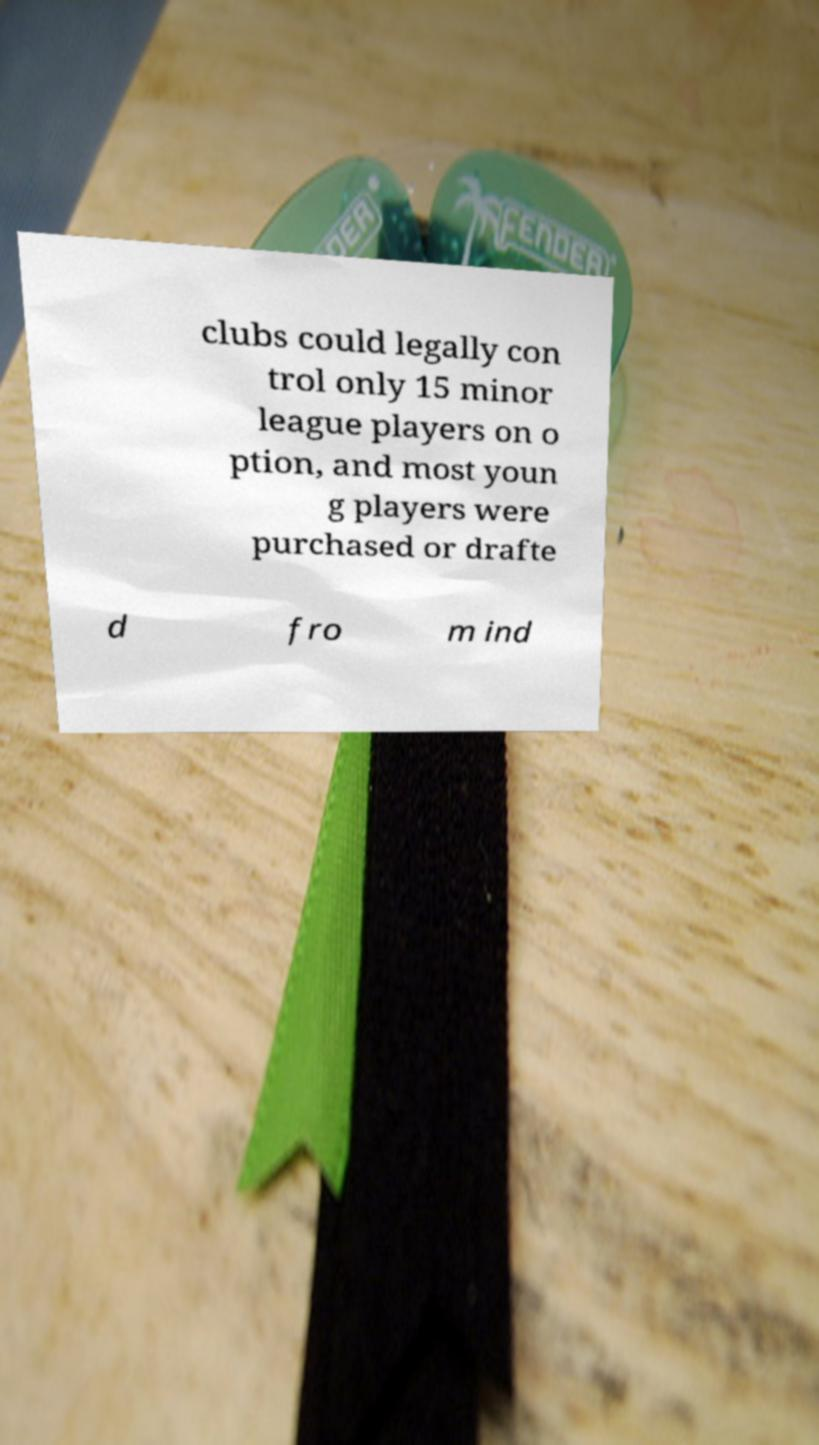For documentation purposes, I need the text within this image transcribed. Could you provide that? clubs could legally con trol only 15 minor league players on o ption, and most youn g players were purchased or drafte d fro m ind 